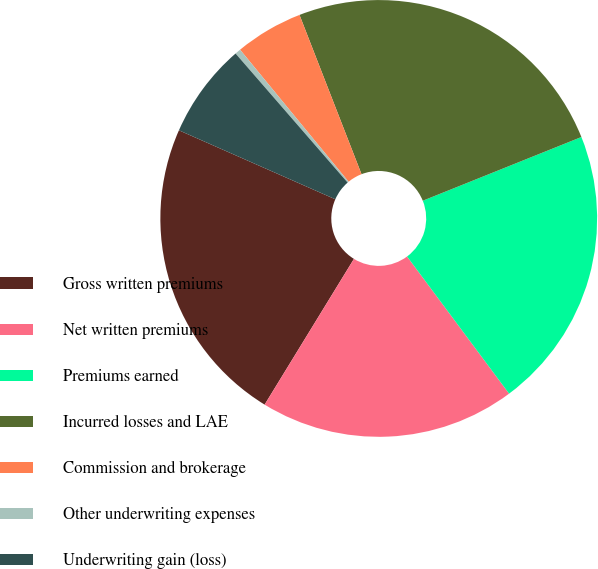<chart> <loc_0><loc_0><loc_500><loc_500><pie_chart><fcel>Gross written premiums<fcel>Net written premiums<fcel>Premiums earned<fcel>Incurred losses and LAE<fcel>Commission and brokerage<fcel>Other underwriting expenses<fcel>Underwriting gain (loss)<nl><fcel>22.86%<fcel>18.93%<fcel>20.9%<fcel>24.83%<fcel>5.04%<fcel>0.43%<fcel>7.01%<nl></chart> 